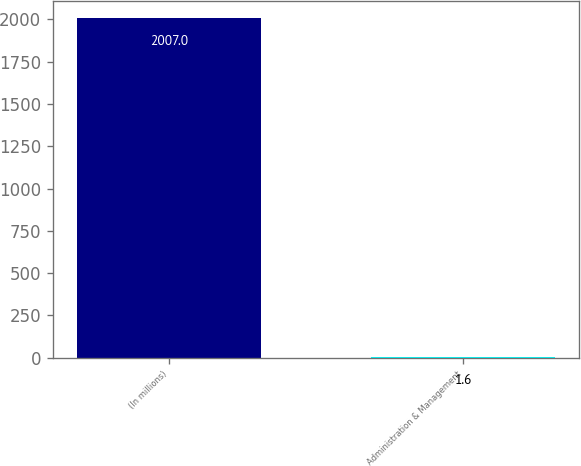<chart> <loc_0><loc_0><loc_500><loc_500><bar_chart><fcel>(In millions)<fcel>Administration & Management<nl><fcel>2007<fcel>1.6<nl></chart> 